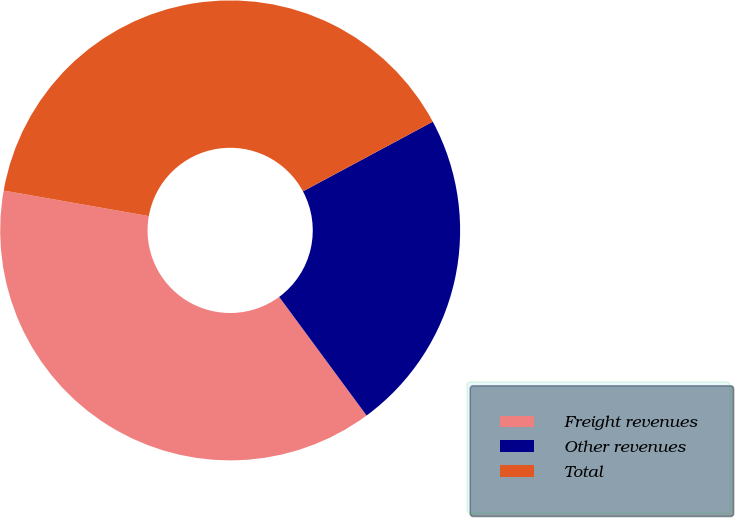Convert chart to OTSL. <chart><loc_0><loc_0><loc_500><loc_500><pie_chart><fcel>Freight revenues<fcel>Other revenues<fcel>Total<nl><fcel>37.88%<fcel>22.73%<fcel>39.39%<nl></chart> 